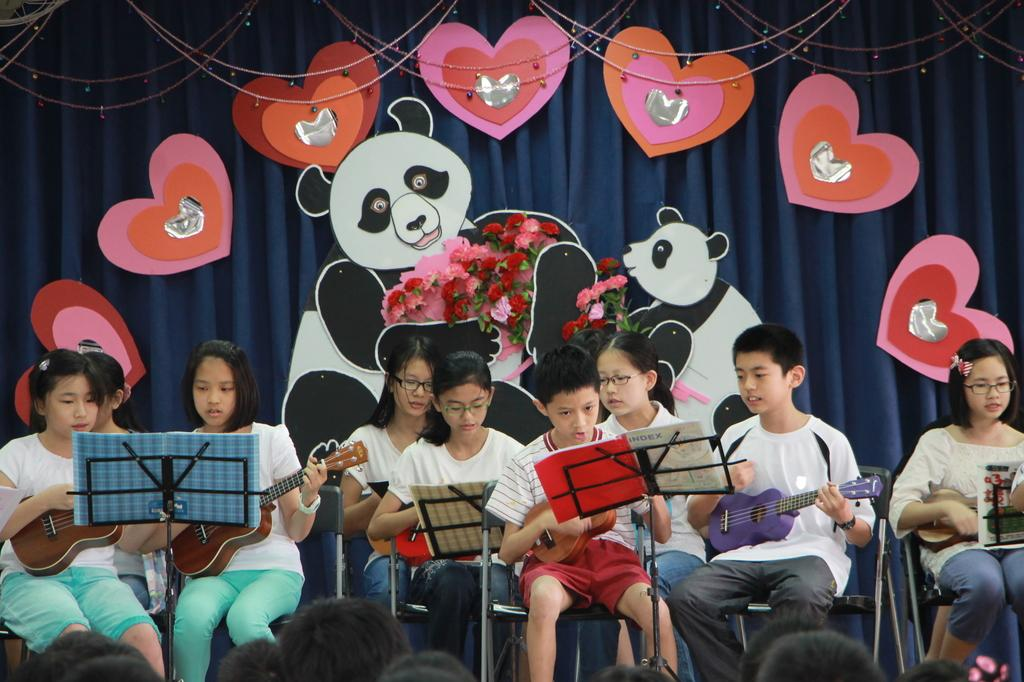What are the people in the image doing? There is a group of people performing in the image. What instruments are the people playing? The people are playing guitars. Where is the performance taking place? The performance is taking place on a dais. Who is watching the performance? There is an audience watching the performance. What type of mailbox can be seen near the dais in the image? There is no mailbox present in the image. Can you tell me how the engine of the guitar is functioning during the performance? Guitars do not have engines; they are musical instruments played by strumming or plucking the strings. 